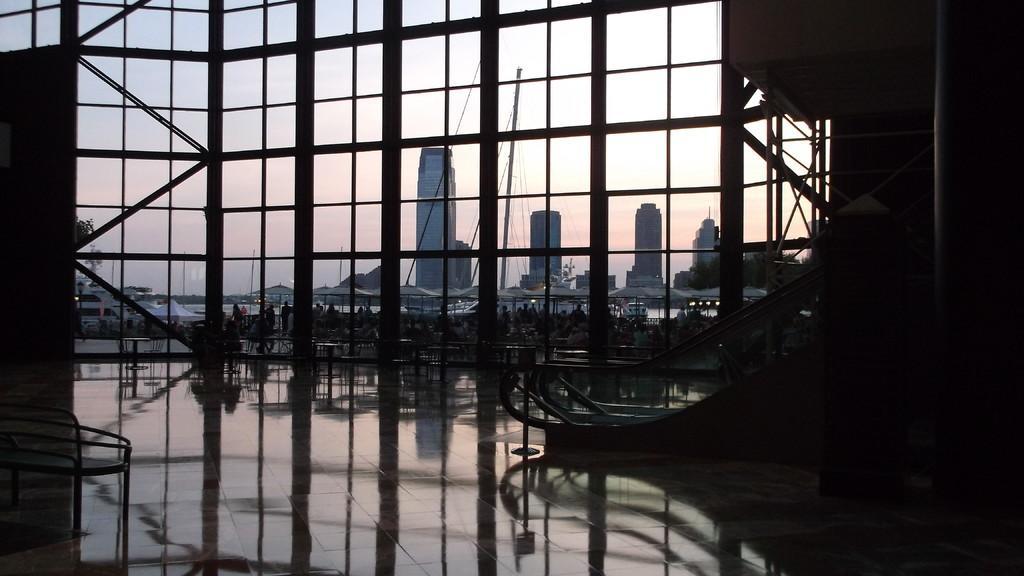In one or two sentences, can you explain what this image depicts? In this image there is floor at the bottom. There is a metal object on the left corner. There is an escalator and it is dark on the right corner. There is glass in the background in which we can see buildings, people, tables and sky. 